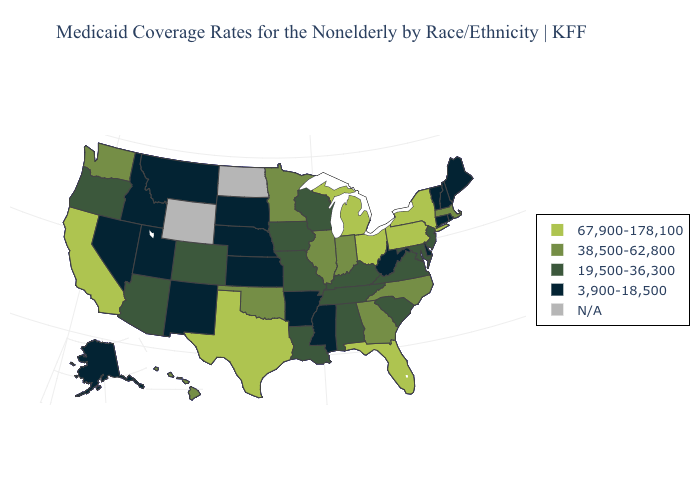Name the states that have a value in the range 3,900-18,500?
Short answer required. Alaska, Arkansas, Connecticut, Delaware, Idaho, Kansas, Maine, Mississippi, Montana, Nebraska, Nevada, New Hampshire, New Mexico, Rhode Island, South Dakota, Utah, Vermont, West Virginia. Name the states that have a value in the range N/A?
Concise answer only. North Dakota, Wyoming. What is the highest value in states that border Minnesota?
Concise answer only. 19,500-36,300. Does Georgia have the lowest value in the USA?
Short answer required. No. What is the value of Nevada?
Keep it brief. 3,900-18,500. Does Tennessee have the lowest value in the South?
Concise answer only. No. Among the states that border Virginia , which have the lowest value?
Be succinct. West Virginia. Which states hav the highest value in the Northeast?
Be succinct. New York, Pennsylvania. What is the value of Nebraska?
Concise answer only. 3,900-18,500. What is the value of Arkansas?
Concise answer only. 3,900-18,500. Name the states that have a value in the range 3,900-18,500?
Short answer required. Alaska, Arkansas, Connecticut, Delaware, Idaho, Kansas, Maine, Mississippi, Montana, Nebraska, Nevada, New Hampshire, New Mexico, Rhode Island, South Dakota, Utah, Vermont, West Virginia. Which states have the lowest value in the Northeast?
Give a very brief answer. Connecticut, Maine, New Hampshire, Rhode Island, Vermont. What is the value of Louisiana?
Be succinct. 19,500-36,300. 